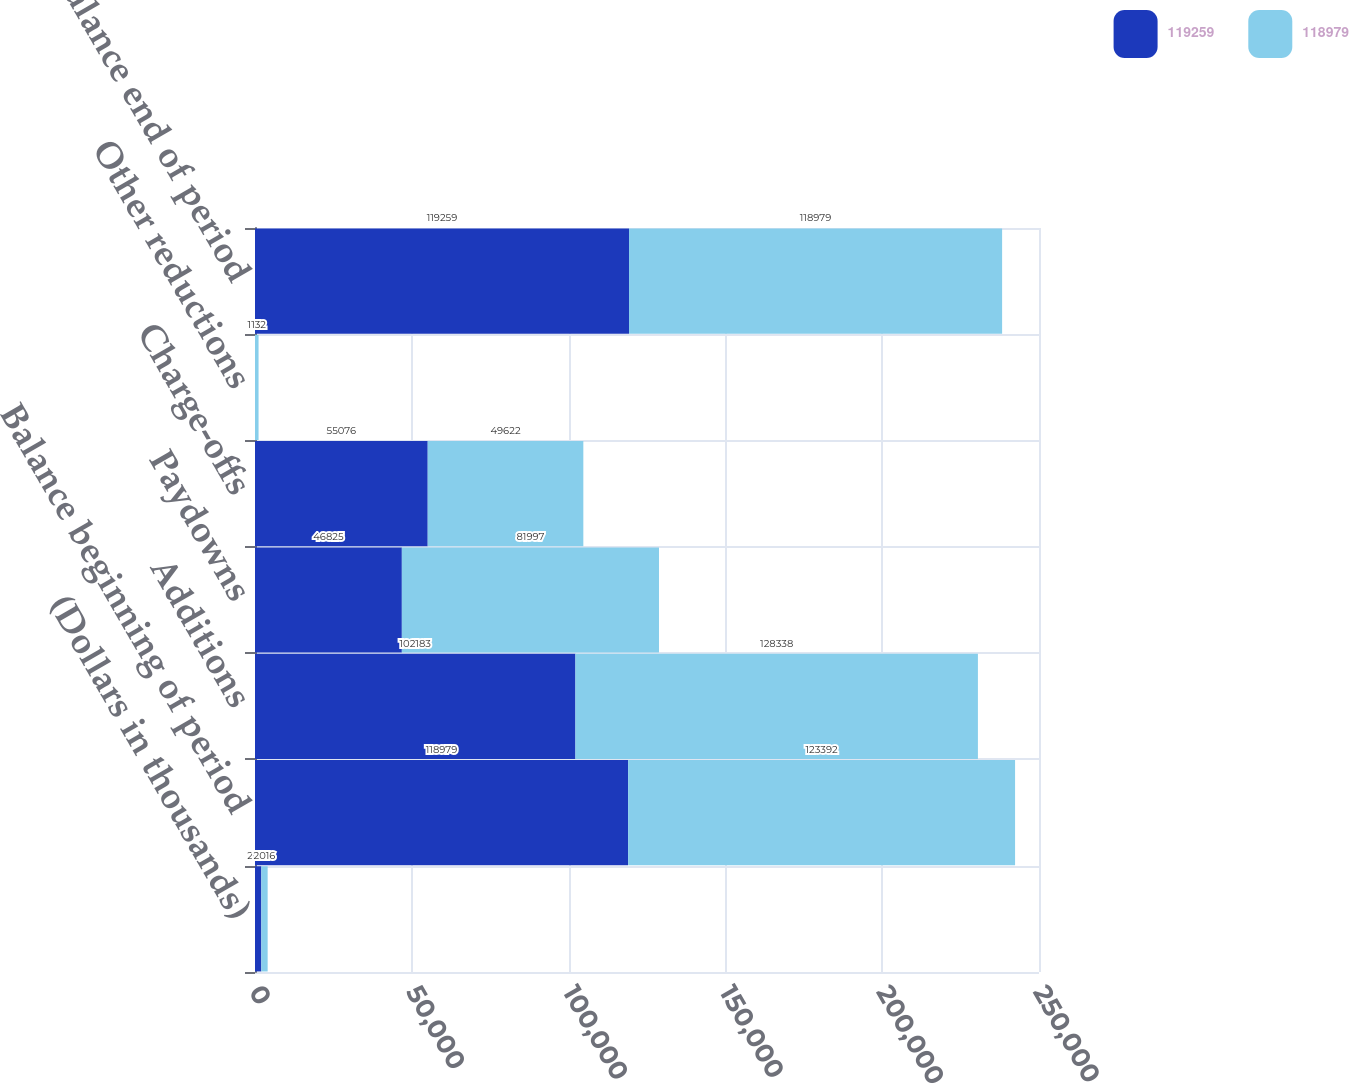<chart> <loc_0><loc_0><loc_500><loc_500><stacked_bar_chart><ecel><fcel>(Dollars in thousands)<fcel>Balance beginning of period<fcel>Additions<fcel>Paydowns<fcel>Charge-offs<fcel>Other reductions<fcel>Balance end of period<nl><fcel>119259<fcel>2017<fcel>118979<fcel>102183<fcel>46825<fcel>55076<fcel>2<fcel>119259<nl><fcel>118979<fcel>2016<fcel>123392<fcel>128338<fcel>81997<fcel>49622<fcel>1132<fcel>118979<nl></chart> 